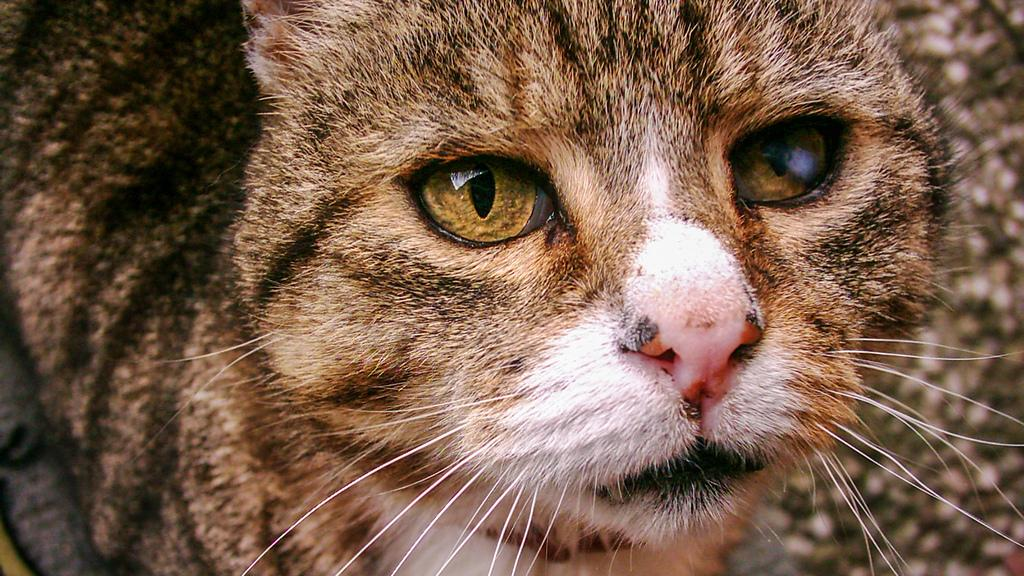What is the main subject of the image? The main subject of the image is a cat. Can you describe the image in more detail? The image is a close-up picture of a cat. What type of care is the cat providing in the image? There is no indication in the image that the cat is providing any care. Is the cat engaged in a battle in the image? There is no battle depicted in the image; it is a close-up picture of a cat. 